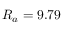<formula> <loc_0><loc_0><loc_500><loc_500>R _ { a } = 9 . 7 9</formula> 